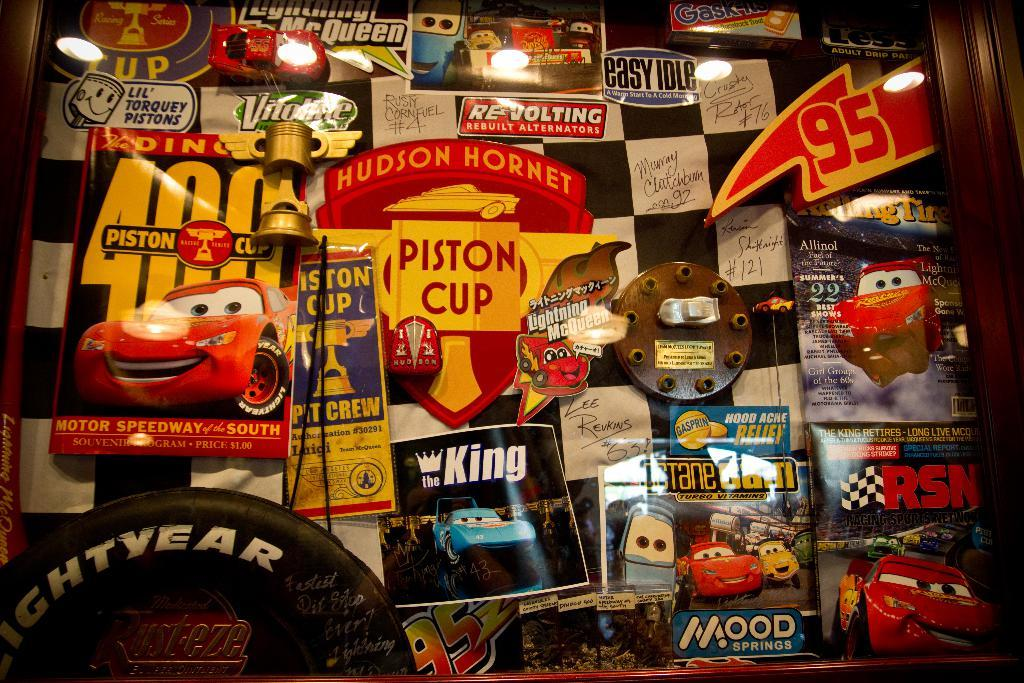What objects can be seen in the image that are used for support or structure? There are posts in the image that are used for support or structure. What type of objects are present in the image that are typically associated with play or entertainment? There are toys in the image that are typically associated with play or entertainment. What general category of objects can be seen in the image? There are things in the image, which can include various objects and items. What objects in the image provide illumination? There are lights in the image that provide illumination. What is the tendency of the bear in the image? There is no bear present in the image, so it is not possible to determine its tendency. How many babies are visible in the image? There are no babies present in the image. 